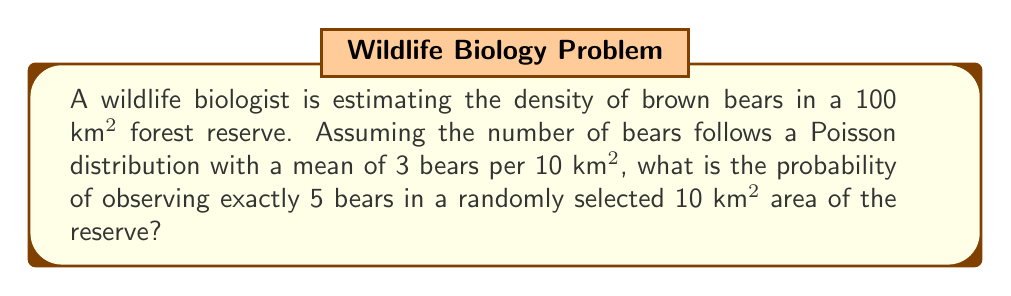Help me with this question. To solve this problem, we'll use the Poisson probability mass function:

$$P(X = k) = \frac{e^{-\lambda} \lambda^k}{k!}$$

Where:
$\lambda$ = mean number of occurrences
$k$ = number of occurrences we're interested in
$e$ = Euler's number (approximately 2.71828)

Given:
$\lambda = 3$ (mean of 3 bears per 10 km²)
$k = 5$ (we want the probability of observing exactly 5 bears)

Step 1: Substitute the values into the Poisson probability mass function:

$$P(X = 5) = \frac{e^{-3} 3^5}{5!}$$

Step 2: Calculate $3^5$:
$$3^5 = 243$$

Step 3: Calculate $5!$:
$$5! = 5 \times 4 \times 3 \times 2 \times 1 = 120$$

Step 4: Calculate $e^{-3}$ (you can use a calculator for this):
$$e^{-3} \approx 0.0497871$$

Step 5: Substitute these values and calculate:

$$P(X = 5) = \frac{0.0497871 \times 243}{120} \approx 0.1008$$

Step 6: Convert to a percentage:
$$0.1008 \times 100\% = 10.08\%$$

This means there's approximately a 10.08% chance of observing exactly 5 bears in a randomly selected 10 km² area of the reserve.
Answer: 10.08% 